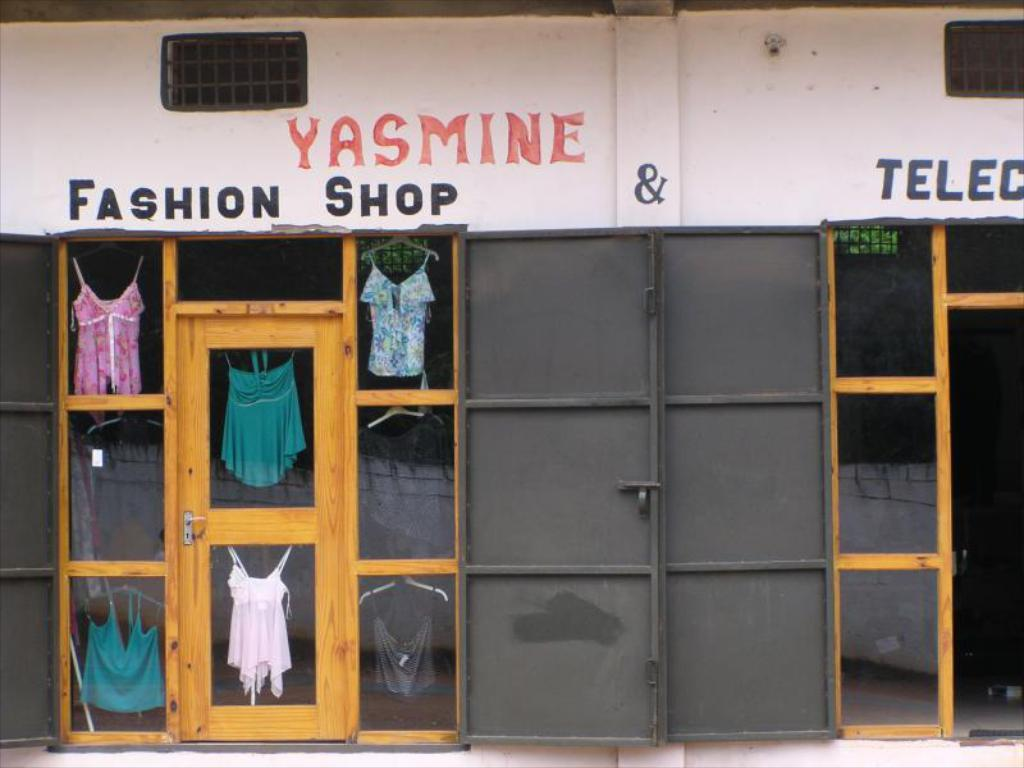<image>
Give a short and clear explanation of the subsequent image. The front entrance of the yasmine fashion shop with clothes hanging on the windows. 